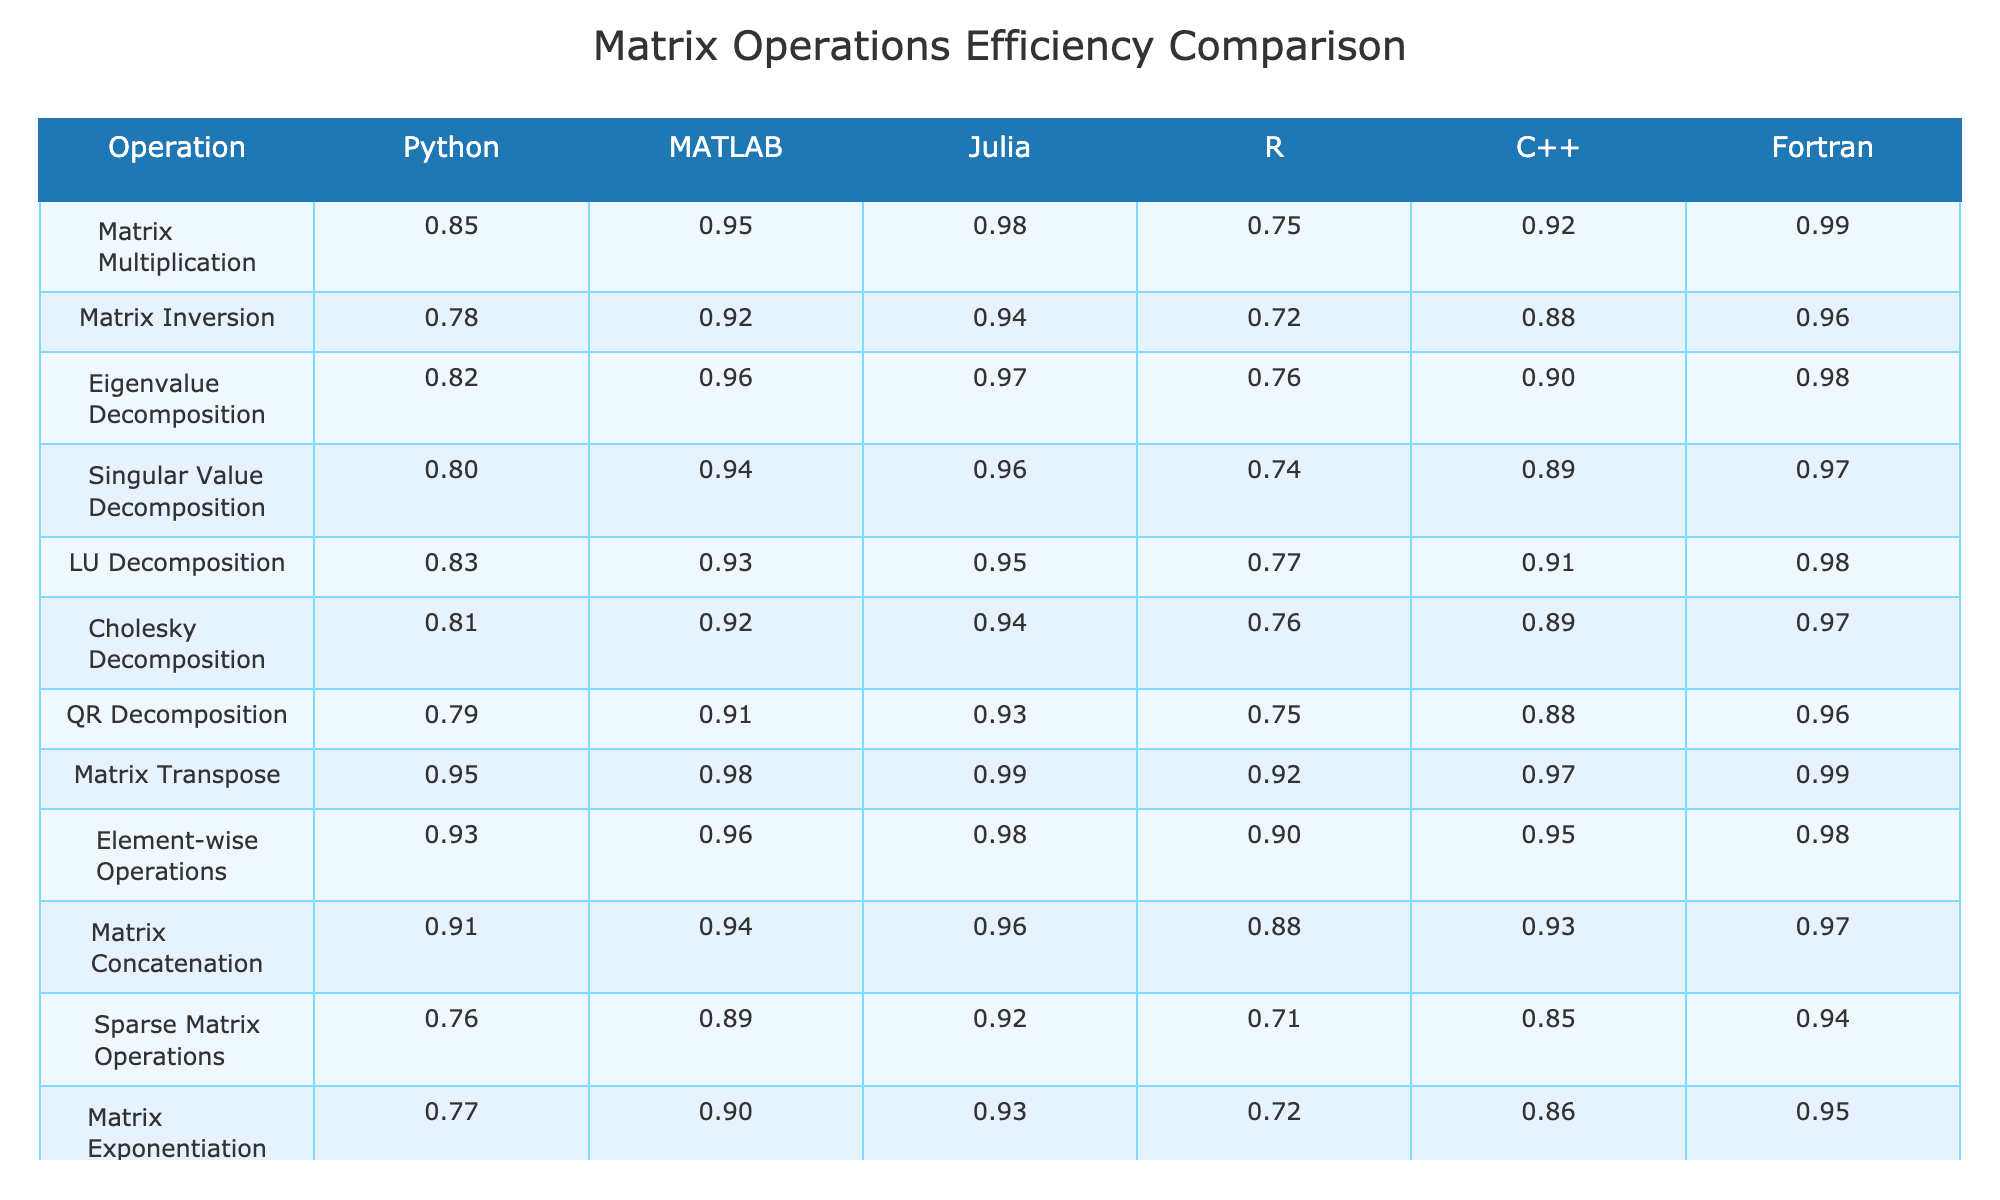What is the efficiency of Matrix Multiplication in C++? Referring to the table, the efficiency value for Matrix Multiplication under C++ is 0.92.
Answer: 0.92 Which programming language has the lowest efficiency for Matrix Inversion? By checking the table, R has the lowest efficiency value for Matrix Inversion at 0.72.
Answer: R What is the average efficiency of LU Decomposition across all programming languages? Adding the efficiency values for LU Decomposition: 0.83 (Python) + 0.93 (MATLAB) + 0.95 (Julia) + 0.77 (R) + 0.91 (C++) + 0.98 (Fortran) = 5.37, and then dividing by 6 gives 5.37 / 6 = 0.895.
Answer: 0.895 Is the efficiency of Eigenvalue Decomposition higher in Julia than in MATLAB? The table shows that Eigenvalue Decomposition has an efficiency of 0.97 in Julia and 0.96 in MATLAB, indicating that Julia's efficiency is indeed higher.
Answer: Yes Which operation has the highest efficiency in Fortran? From the table, the operation with the highest efficiency in Fortran is Matrix Multiplication, which has an efficiency value of 0.99.
Answer: Matrix Multiplication What is the difference in efficiency between Matrix Exponentiation in Python and C++? The efficiency for Matrix Exponentiation is 0.77 in Python and 0.86 in C++; thus, the difference is 0.86 - 0.77 = 0.09.
Answer: 0.09 Do all programming languages show efficiency values for Matrix Transpose above 0.90? The table confirms that all programming languages listed (Python, MATLAB, Julia, R, C++, and Fortran) have efficiency values for Matrix Transpose above 0.90, which means the statement is true.
Answer: Yes If you sum the efficiencies of Element-wise Operations across all languages, what is the total? Summing the values: 0.93 (Python) + 0.96 (MATLAB) + 0.98 (Julia) + 0.90 (R) + 0.95 (C++) + 0.98 (Fortran) = 5.70.
Answer: 5.70 Which programming language has the most consistent efficiency across the various matrix operations? Looking at the table, Fortran has relatively high efficiency values across almost all operations, with none being below 0.94, indicating consistency.
Answer: Fortran Which operation features the least efficient implementation across all programming languages? By analyzing the table, Sparse Matrix Operations has the lowest maximum efficiency at 0.76 (Python).
Answer: Sparse Matrix Operations 